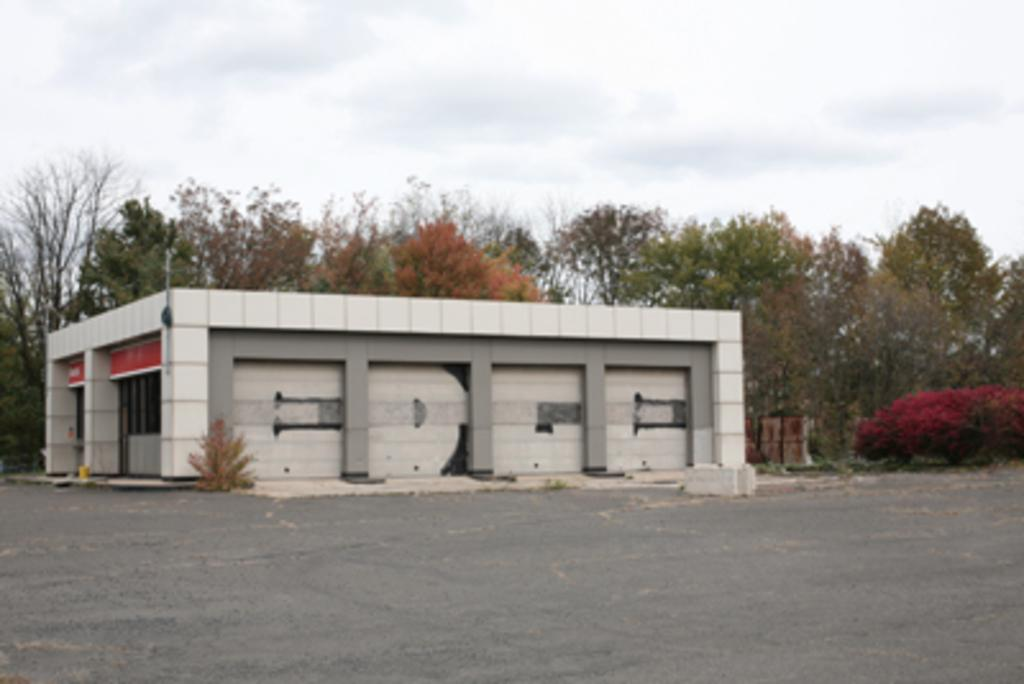What type of structure is present in the image? There is a building in the image. What other natural elements can be seen in the image? There are plants and trees in the image. What is visible at the top of the image? The sky is visible at the top of the image. What is visible at the bottom of the image? The road is visible at the bottom of the image. Can you see a knife being used by someone in the image? There is no knife or person using a knife present in the image. 